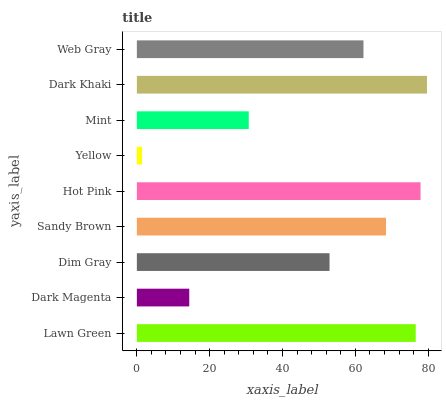Is Yellow the minimum?
Answer yes or no. Yes. Is Dark Khaki the maximum?
Answer yes or no. Yes. Is Dark Magenta the minimum?
Answer yes or no. No. Is Dark Magenta the maximum?
Answer yes or no. No. Is Lawn Green greater than Dark Magenta?
Answer yes or no. Yes. Is Dark Magenta less than Lawn Green?
Answer yes or no. Yes. Is Dark Magenta greater than Lawn Green?
Answer yes or no. No. Is Lawn Green less than Dark Magenta?
Answer yes or no. No. Is Web Gray the high median?
Answer yes or no. Yes. Is Web Gray the low median?
Answer yes or no. Yes. Is Yellow the high median?
Answer yes or no. No. Is Mint the low median?
Answer yes or no. No. 